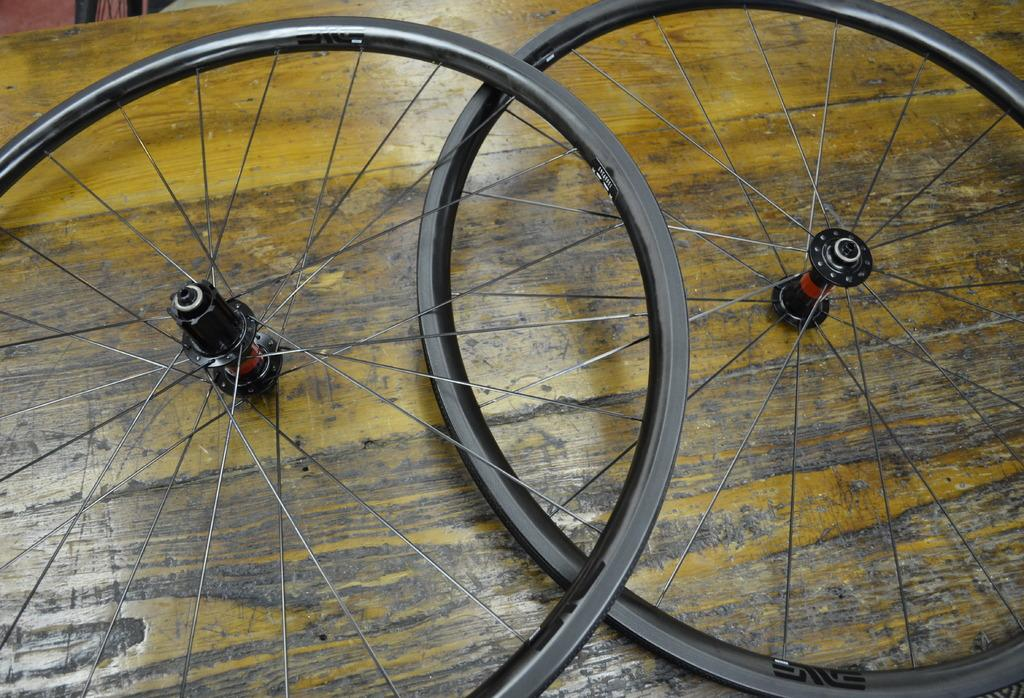What objects are present in the image? There are two wheels in the image. What is the wheels placed on? The wheels are placed on a wooden surface. What type of cannon is present in the image? There is no cannon present in the image; it only features two wheels placed on a wooden surface. How many bubbles can be seen in the image? There are no bubbles present in the image; it only features two wheels placed on a wooden surface. 